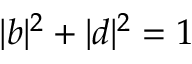Convert formula to latex. <formula><loc_0><loc_0><loc_500><loc_500>| b | ^ { 2 } + | d | ^ { 2 } = 1</formula> 